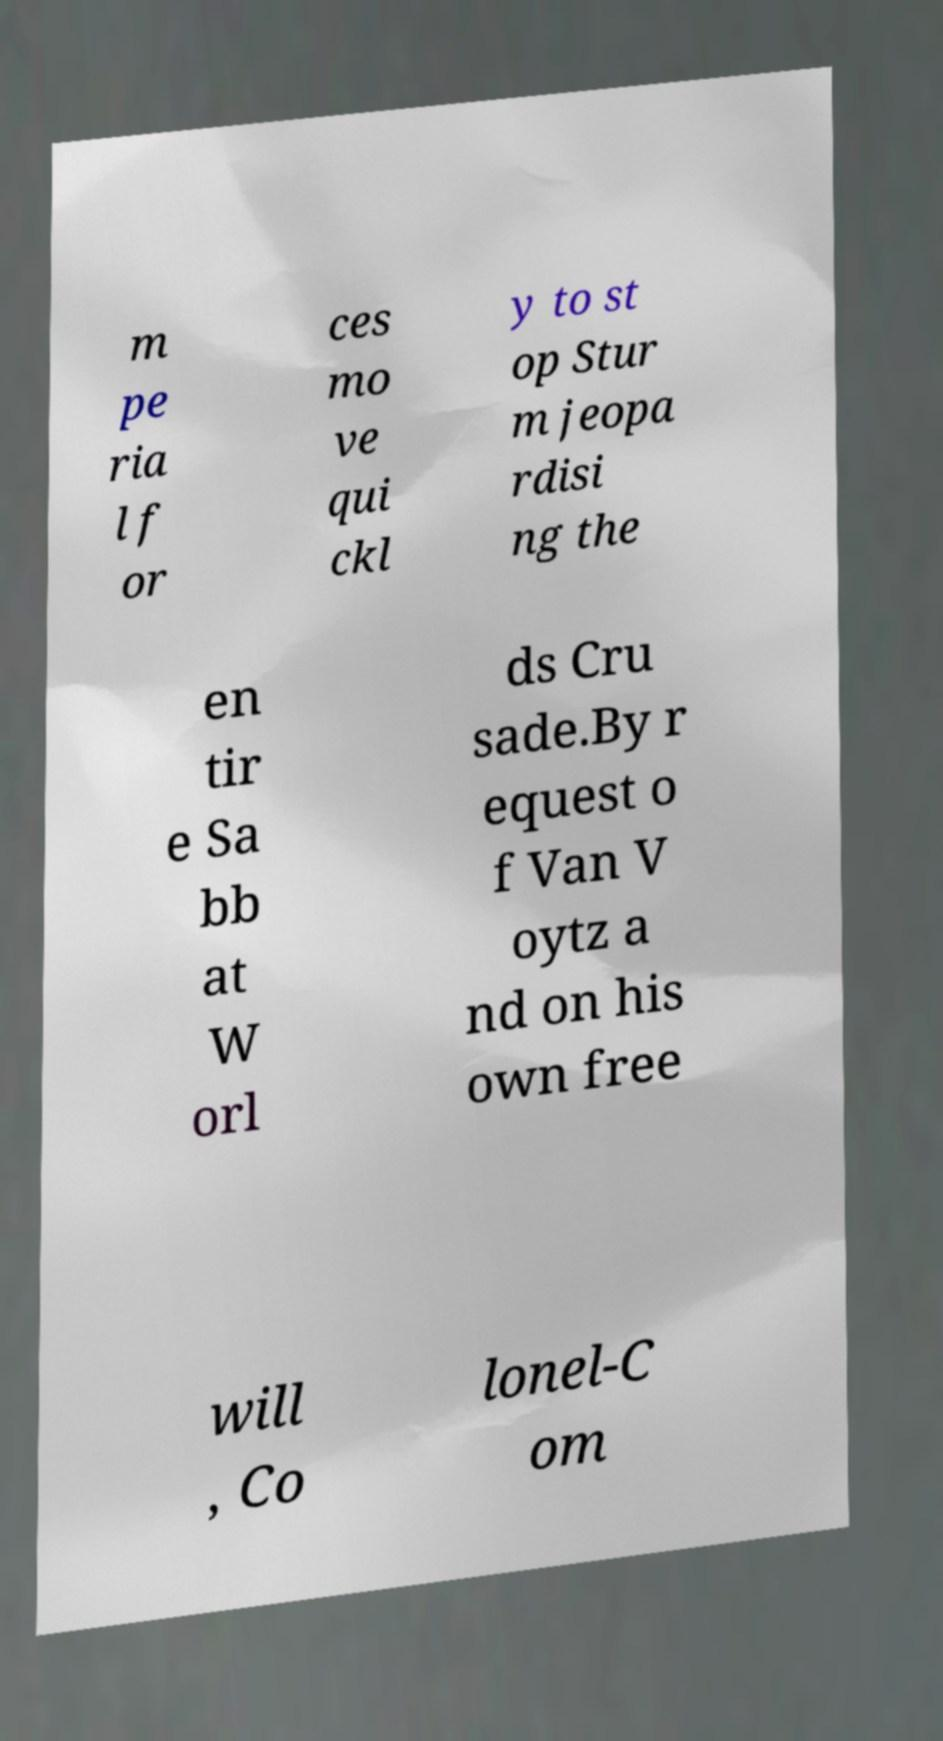What messages or text are displayed in this image? I need them in a readable, typed format. m pe ria l f or ces mo ve qui ckl y to st op Stur m jeopa rdisi ng the en tir e Sa bb at W orl ds Cru sade.By r equest o f Van V oytz a nd on his own free will , Co lonel-C om 